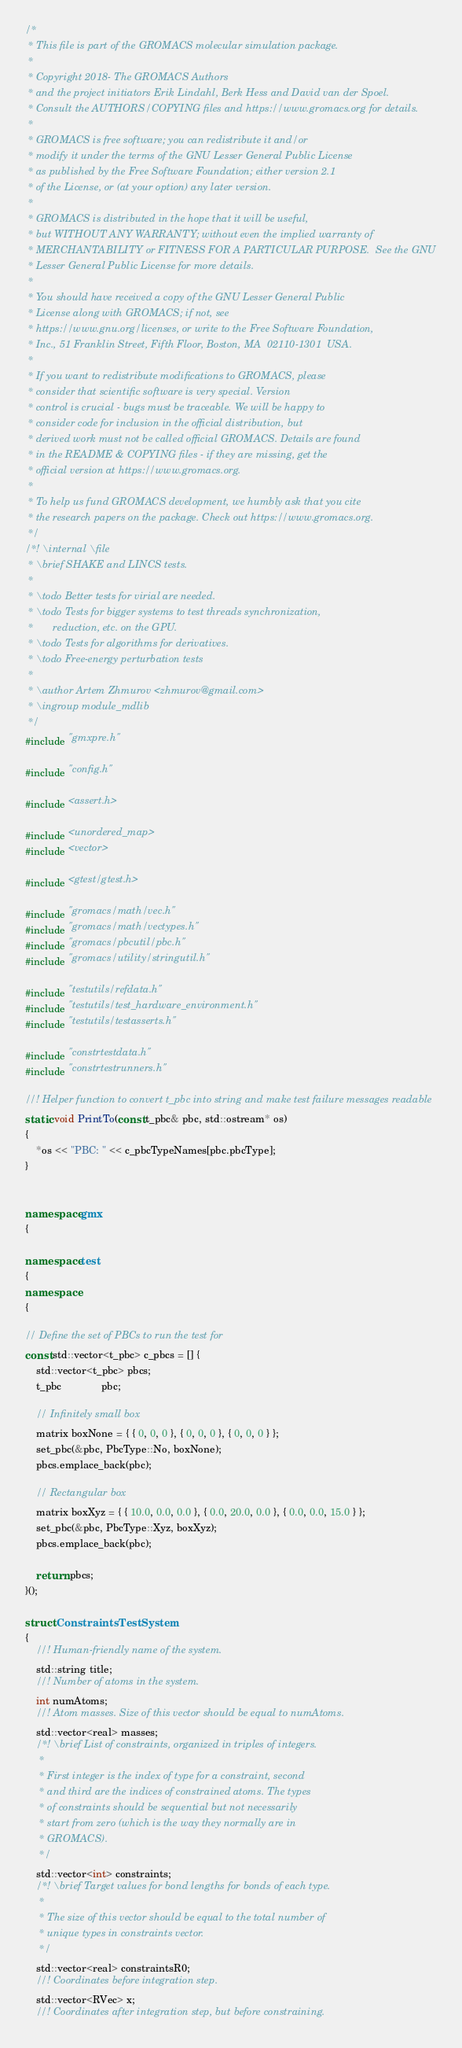<code> <loc_0><loc_0><loc_500><loc_500><_C++_>/*
 * This file is part of the GROMACS molecular simulation package.
 *
 * Copyright 2018- The GROMACS Authors
 * and the project initiators Erik Lindahl, Berk Hess and David van der Spoel.
 * Consult the AUTHORS/COPYING files and https://www.gromacs.org for details.
 *
 * GROMACS is free software; you can redistribute it and/or
 * modify it under the terms of the GNU Lesser General Public License
 * as published by the Free Software Foundation; either version 2.1
 * of the License, or (at your option) any later version.
 *
 * GROMACS is distributed in the hope that it will be useful,
 * but WITHOUT ANY WARRANTY; without even the implied warranty of
 * MERCHANTABILITY or FITNESS FOR A PARTICULAR PURPOSE.  See the GNU
 * Lesser General Public License for more details.
 *
 * You should have received a copy of the GNU Lesser General Public
 * License along with GROMACS; if not, see
 * https://www.gnu.org/licenses, or write to the Free Software Foundation,
 * Inc., 51 Franklin Street, Fifth Floor, Boston, MA  02110-1301  USA.
 *
 * If you want to redistribute modifications to GROMACS, please
 * consider that scientific software is very special. Version
 * control is crucial - bugs must be traceable. We will be happy to
 * consider code for inclusion in the official distribution, but
 * derived work must not be called official GROMACS. Details are found
 * in the README & COPYING files - if they are missing, get the
 * official version at https://www.gromacs.org.
 *
 * To help us fund GROMACS development, we humbly ask that you cite
 * the research papers on the package. Check out https://www.gromacs.org.
 */
/*! \internal \file
 * \brief SHAKE and LINCS tests.
 *
 * \todo Better tests for virial are needed.
 * \todo Tests for bigger systems to test threads synchronization,
 *       reduction, etc. on the GPU.
 * \todo Tests for algorithms for derivatives.
 * \todo Free-energy perturbation tests
 *
 * \author Artem Zhmurov <zhmurov@gmail.com>
 * \ingroup module_mdlib
 */
#include "gmxpre.h"

#include "config.h"

#include <assert.h>

#include <unordered_map>
#include <vector>

#include <gtest/gtest.h>

#include "gromacs/math/vec.h"
#include "gromacs/math/vectypes.h"
#include "gromacs/pbcutil/pbc.h"
#include "gromacs/utility/stringutil.h"

#include "testutils/refdata.h"
#include "testutils/test_hardware_environment.h"
#include "testutils/testasserts.h"

#include "constrtestdata.h"
#include "constrtestrunners.h"

//! Helper function to convert t_pbc into string and make test failure messages readable
static void PrintTo(const t_pbc& pbc, std::ostream* os)
{
    *os << "PBC: " << c_pbcTypeNames[pbc.pbcType];
}


namespace gmx
{

namespace test
{
namespace
{

// Define the set of PBCs to run the test for
const std::vector<t_pbc> c_pbcs = [] {
    std::vector<t_pbc> pbcs;
    t_pbc              pbc;

    // Infinitely small box
    matrix boxNone = { { 0, 0, 0 }, { 0, 0, 0 }, { 0, 0, 0 } };
    set_pbc(&pbc, PbcType::No, boxNone);
    pbcs.emplace_back(pbc);

    // Rectangular box
    matrix boxXyz = { { 10.0, 0.0, 0.0 }, { 0.0, 20.0, 0.0 }, { 0.0, 0.0, 15.0 } };
    set_pbc(&pbc, PbcType::Xyz, boxXyz);
    pbcs.emplace_back(pbc);

    return pbcs;
}();

struct ConstraintsTestSystem
{
    //! Human-friendly name of the system.
    std::string title;
    //! Number of atoms in the system.
    int numAtoms;
    //! Atom masses. Size of this vector should be equal to numAtoms.
    std::vector<real> masses;
    /*! \brief List of constraints, organized in triples of integers.
     *
     * First integer is the index of type for a constraint, second
     * and third are the indices of constrained atoms. The types
     * of constraints should be sequential but not necessarily
     * start from zero (which is the way they normally are in
     * GROMACS).
     */
    std::vector<int> constraints;
    /*! \brief Target values for bond lengths for bonds of each type.
     *
     * The size of this vector should be equal to the total number of
     * unique types in constraints vector.
     */
    std::vector<real> constraintsR0;
    //! Coordinates before integration step.
    std::vector<RVec> x;
    //! Coordinates after integration step, but before constraining.</code> 